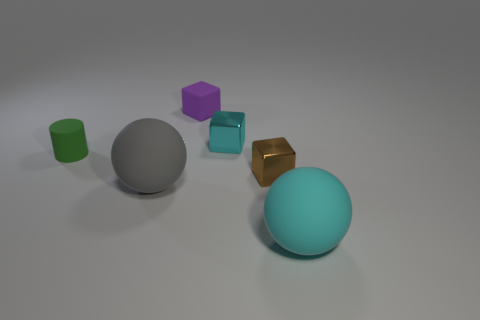Subtract all cyan shiny blocks. How many blocks are left? 2 Add 4 cubes. How many objects exist? 10 Subtract all cylinders. How many objects are left? 5 Subtract 0 brown balls. How many objects are left? 6 Subtract all gray matte objects. Subtract all tiny brown metallic blocks. How many objects are left? 4 Add 2 brown cubes. How many brown cubes are left? 3 Add 4 tiny purple matte things. How many tiny purple matte things exist? 5 